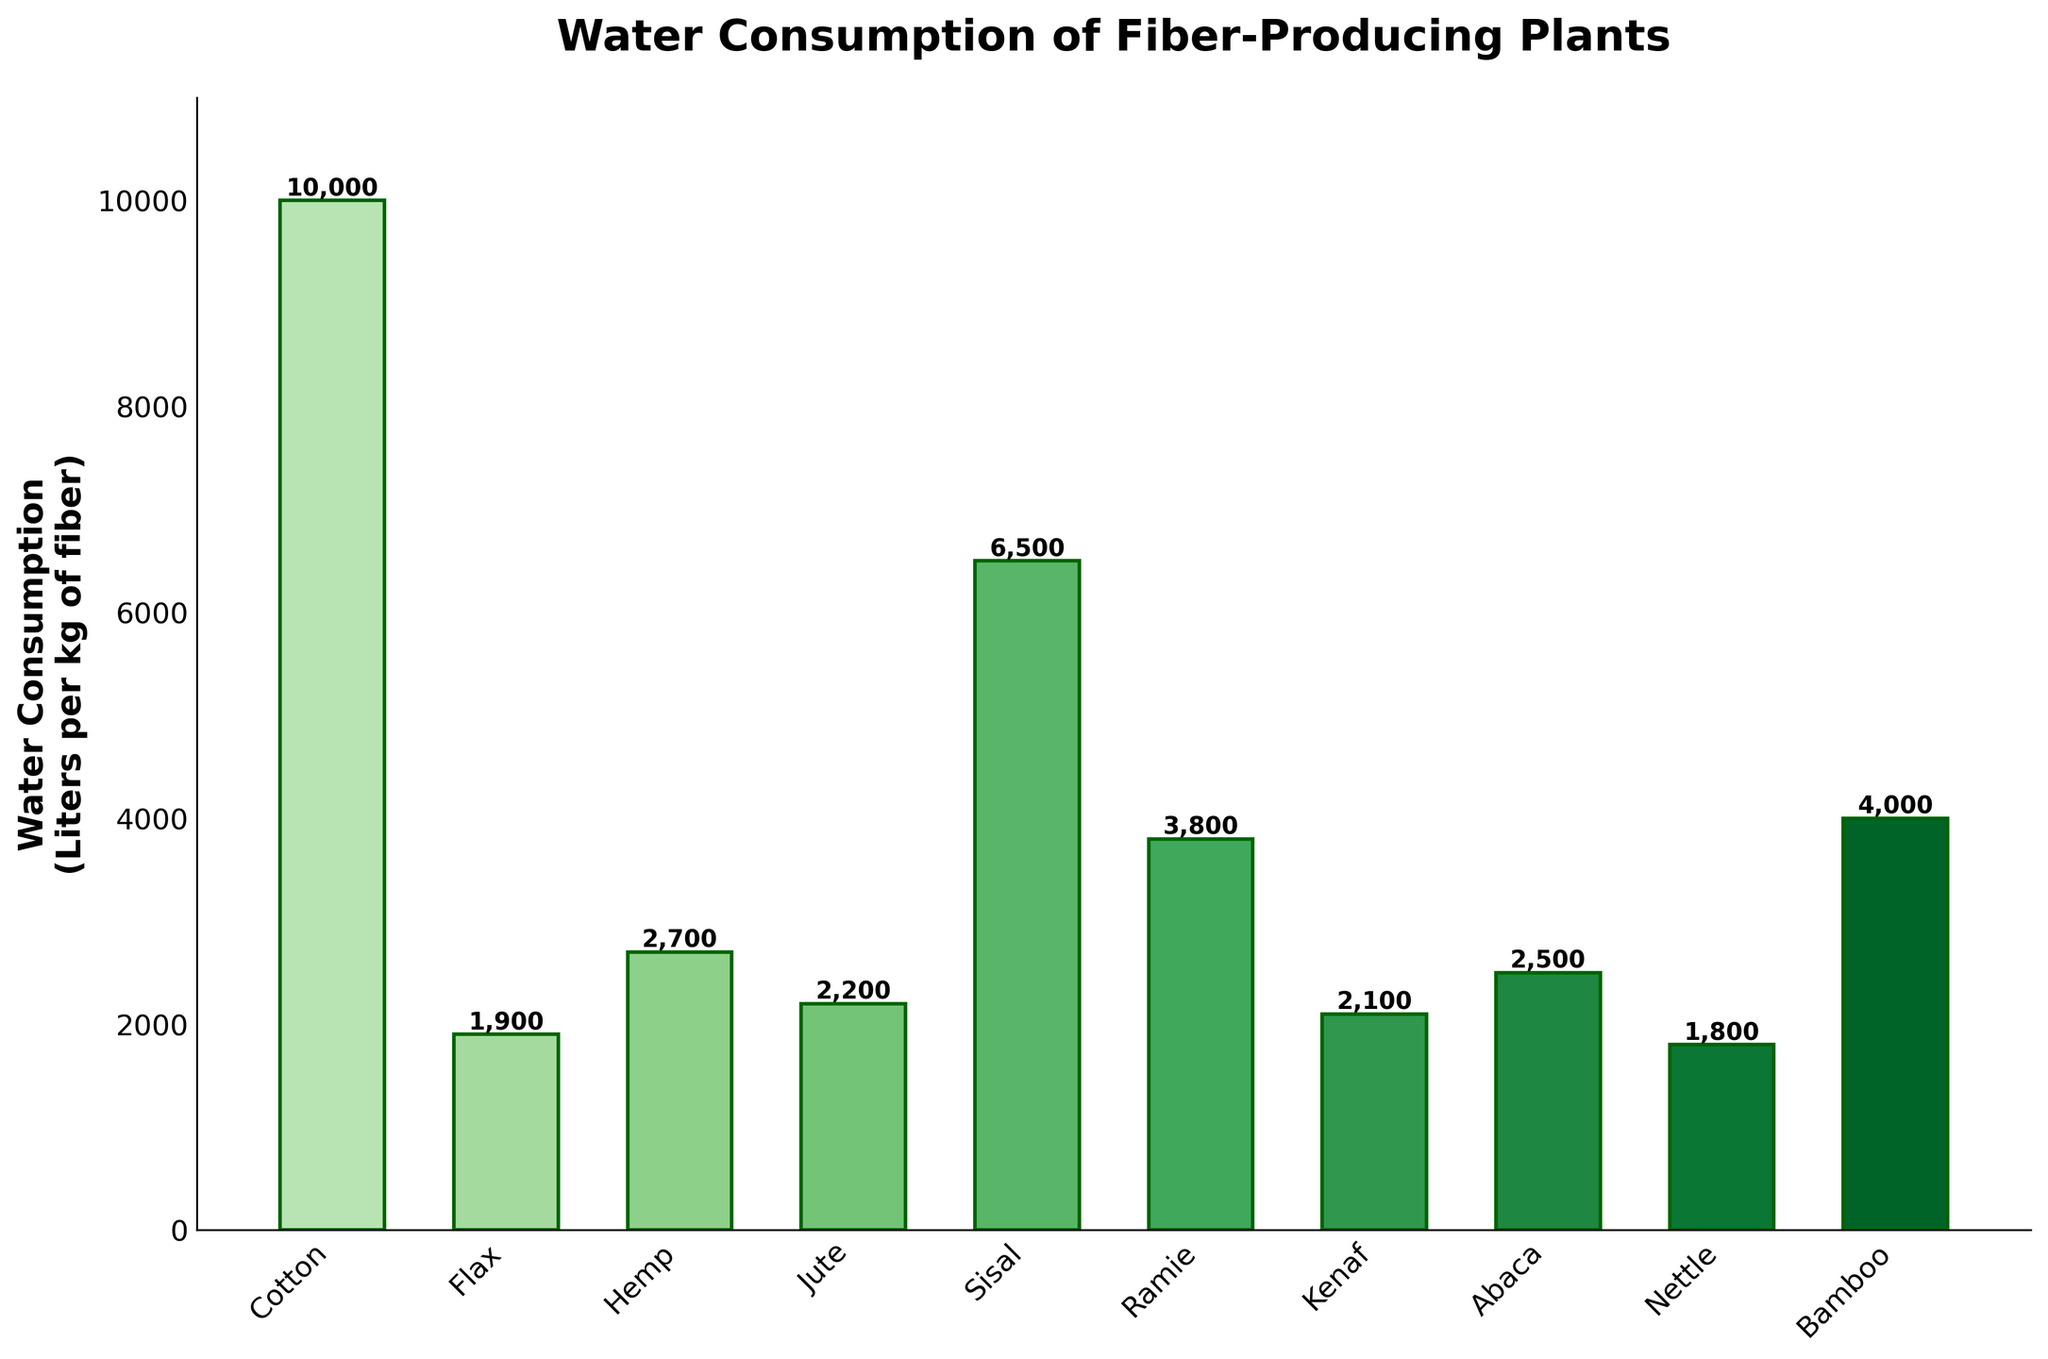What's the median water consumption of the fiber-producing plants? To find the median, list the water consumption values in ascending order: 1800, 1900, 2100, 2200, 2500, 2700, 3800, 4000, 6500, 10000. The middle values (5th and 6th) are 2500 and 2700. The median is the average of these two, i.e., (2500 + 2700) / 2 = 2600
Answer: 2600 Which plant species has the highest water consumption? From the figure, it can be observed that Cotton has the tallest bar, indicating it has the highest water consumption
Answer: Cotton What is the total water consumption for Flax and Nettle combined? From the figure, Flax's water consumption is 1900 liters, and Nettle's is 1800 liters. Summing these gives 1900 + 1800 = 3700 liters
Answer: 3700 Which plant uses less water, Kenaf or Hemp? By comparing the heights of the bars, Kenaf uses 2100 liters, which is less than Hemp, which uses 2700 liters
Answer: Kenaf What is the difference in water consumption between Sisal and Bamboo? Sisal's water consumption is 6500 liters per kg of fiber, while Bamboo's is 4000 liters. The difference is 6500 - 4000 = 2500 liters
Answer: 2500 How does the water consumption of Abaca compare to Ramie? Abaca's water consumption is 2500 liters per kg of fiber, whereas Ramie consumes 3800 liters. Thus, Abaca uses less water than Ramie
Answer: Abaca uses less water Can you identify the plant with the lowest water consumption? The shortest bar in the figure corresponds to Nettle, which has the lowest water consumption
Answer: Nettle What is the average water consumption of all listed fiber-producing plants? The sum of all water consumptions is 10000 + 1900 + 2700 + 2200 + 6500 + 3800 + 2100 + 2500 + 1800 + 4000 = 35400. There are 10 plants, so the average is 35400 / 10 = 3540 liters per kg of fiber
Answer: 3540 Identify a plant that uses around 2000 liters of water for fiber production. From the figure, plants with water consumption around 2000 liters are Flax (1900 liters) and Kenaf (2100 liters)
Answer: Flax and Kenaf 